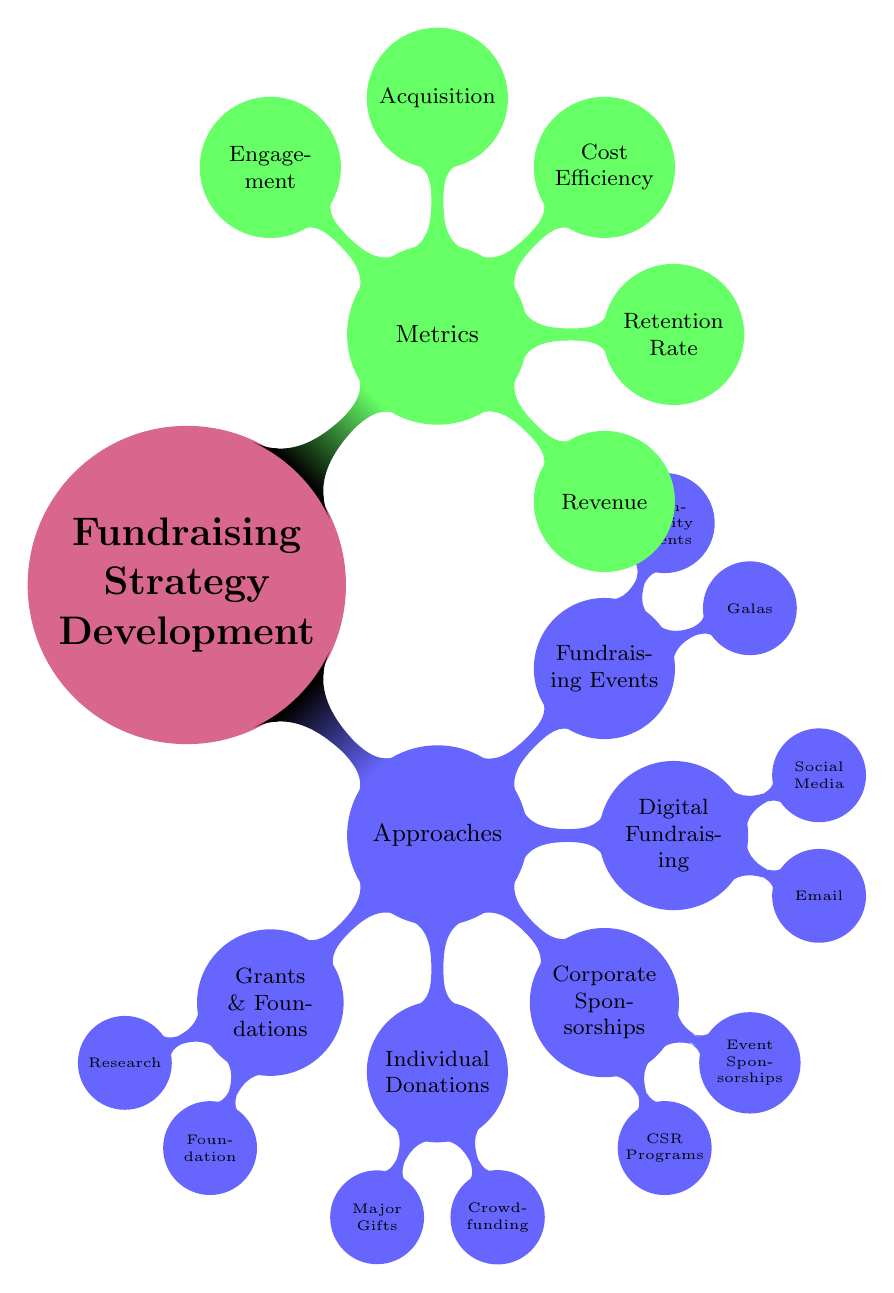What are the main categories of fundraising approaches? The diagram outlines five primary categories under "Approaches": Grants and Foundations, Individual Donations, Corporate Sponsorships, Digital Fundraising, and Fundraising Events.
Answer: Grants and Foundations, Individual Donations, Corporate Sponsorships, Digital Fundraising, Fundraising Events How many types of individual donations are mentioned? Under "Individual Donations," there are two specific types identified: Major Gifts and Crowdfunding.
Answer: 2 What metric measures the percentage of returning donors? The diagram specifies "Donor Retention Rate" as the metric that indicates the percentage of donors who continue to give to the organization.
Answer: Donor Retention Rate Which corporate sponsorship category includes programs related to social responsibility? Within the "Corporate Sponsorships" category, the subcategory "Partnership Development" includes "Corporate Social Responsibility Programs," indicating a focus on social good through corporate engagement.
Answer: Corporate Social Responsibility Programs What fundraising approach is associated with platforms like GoFundMe? Under "Individual Donations," the term "Crowdfunding" is linked directly to platforms such as GoFundMe, indicating a method for gathering funds from a large number of people.
Answer: Crowdfunding What is the primary measure of fundraising efficiency? The diagram presents "Cost per Dollar Raised" as the key metric that evaluates the efficiency of fundraising efforts by comparing costs to the revenue generated.
Answer: Cost per Dollar Raised Which type of fundraising event is represented by "Annual Fundraising Dinners"? In the "Fundraising Events" category, "Charity Galas" specifically represent events like "Annual Fundraising Dinners," emphasizing formal fundraising activities.
Answer: Charity Galas How is social media engagement quantified according to the diagram? The diagram classifies "Social Media Engagement" as quantified by metrics such as likes, shares, and follows, reflecting interaction levels on social platforms.
Answer: Likes, Shares, Follows What is the relationship between digital fundraising and email campaigns? The "Digital Fundraising" category includes "Email Campaigns" as one of its subcategories, suggesting that email is a tool used within digital strategies to solicit donations and communicate with donors.
Answer: Email Campaigns 